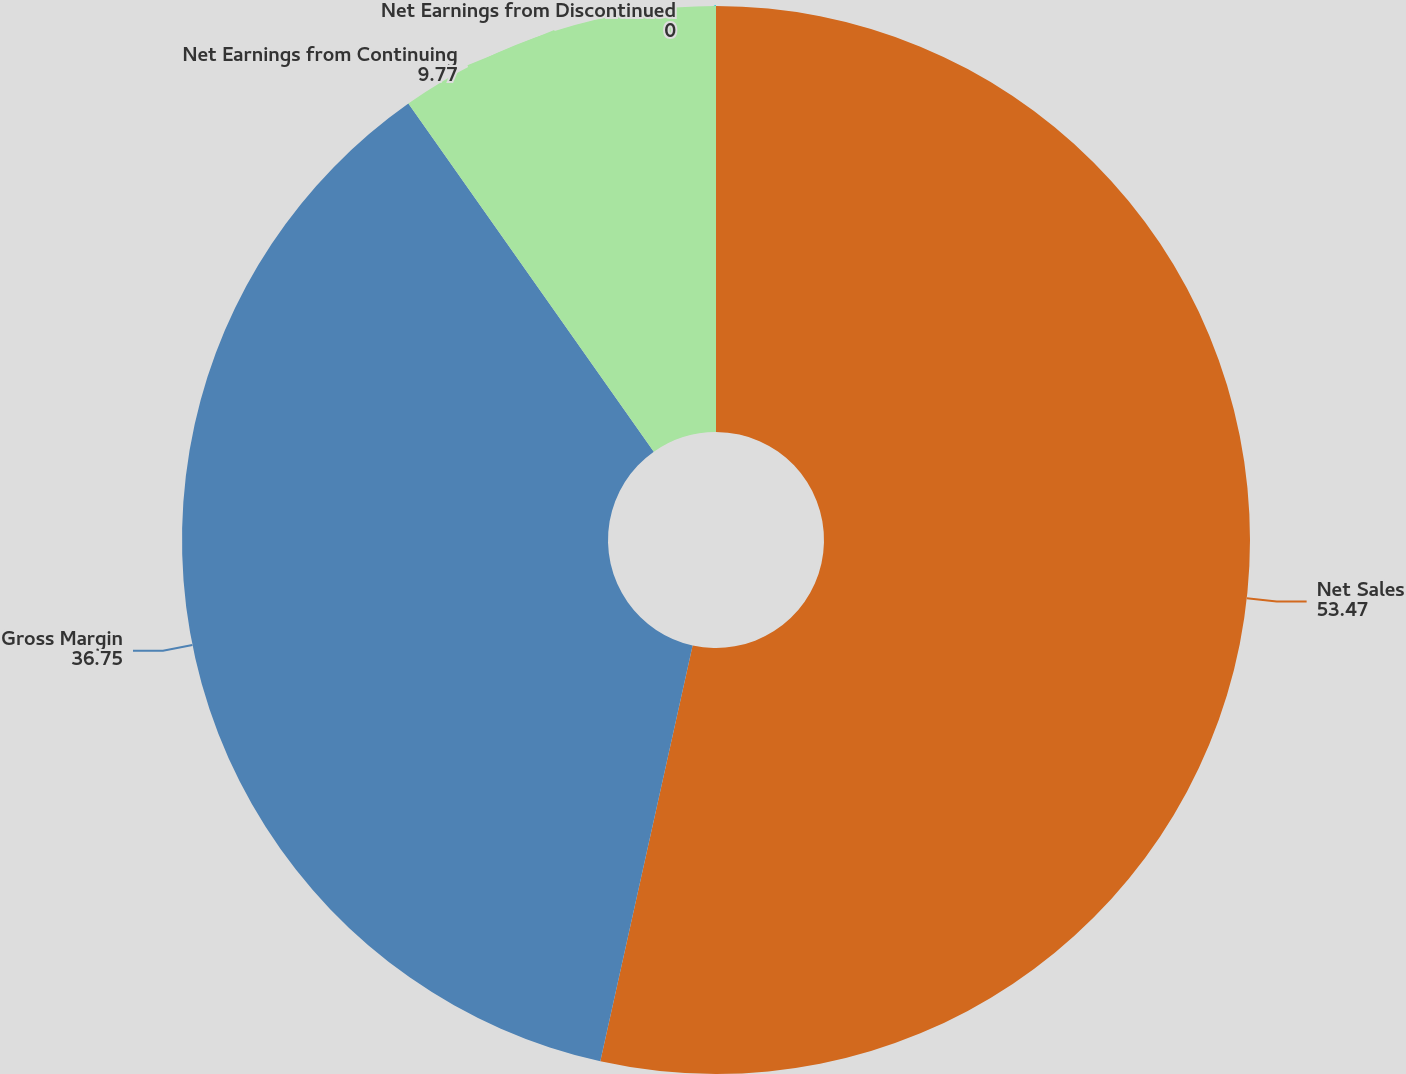Convert chart to OTSL. <chart><loc_0><loc_0><loc_500><loc_500><pie_chart><fcel>Net Sales<fcel>Gross Margin<fcel>Net Earnings from Continuing<fcel>Net Earnings from Discontinued<nl><fcel>53.47%<fcel>36.75%<fcel>9.77%<fcel>0.0%<nl></chart> 